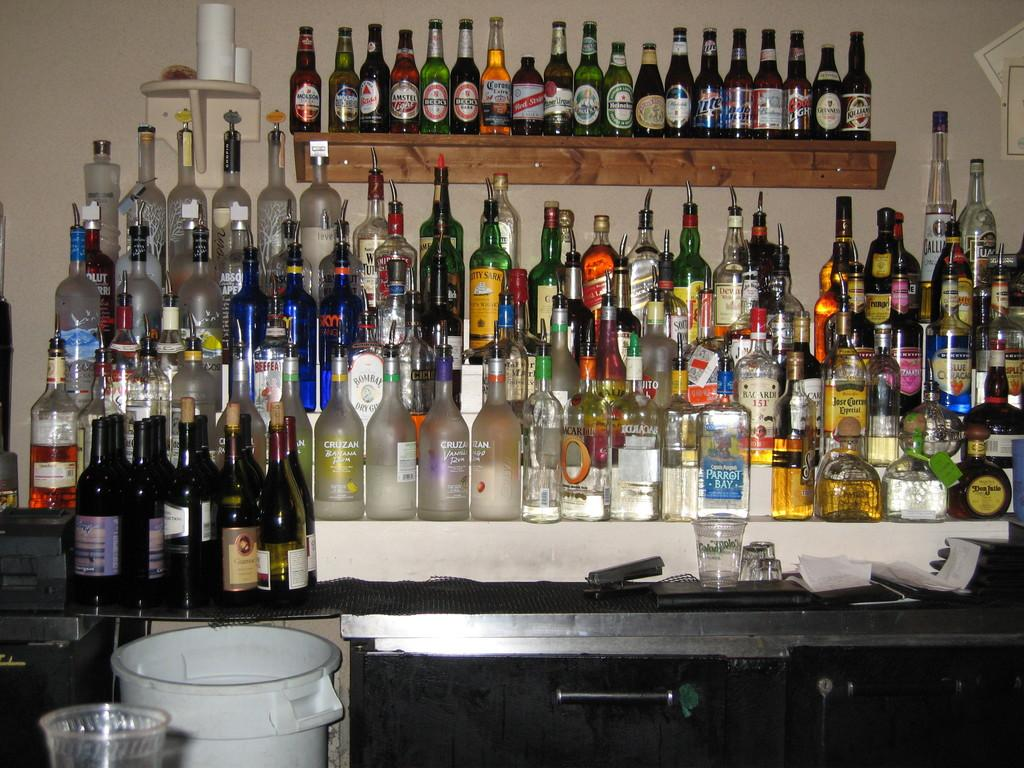What type of bottles are arranged in the image? There are wine bottles in the image. Where are the wine bottles located? The wine bottles are arranged on a table and a rack. What other object can be seen in the image? There is a dustbin in the image. How many chairs are visible in the image? There are no chairs visible in the image. What type of art is displayed on the wine bottles? The wine bottles do not have any art displayed on them; they are simply bottles containing wine. 